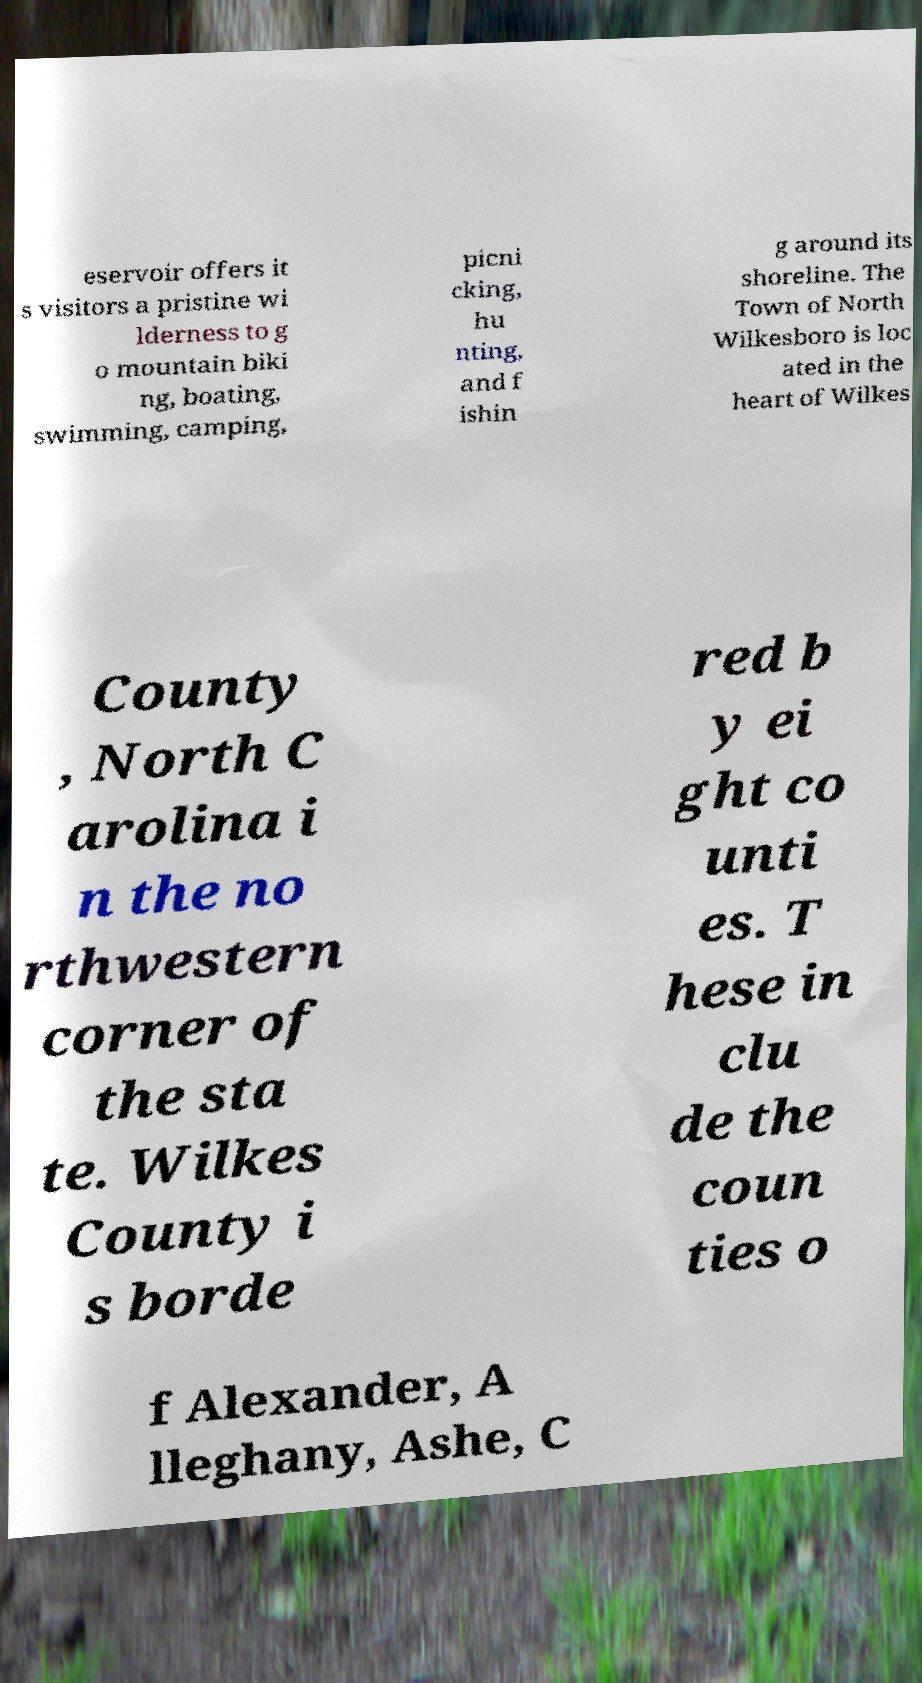Please read and relay the text visible in this image. What does it say? eservoir offers it s visitors a pristine wi lderness to g o mountain biki ng, boating, swimming, camping, picni cking, hu nting, and f ishin g around its shoreline. The Town of North Wilkesboro is loc ated in the heart of Wilkes County , North C arolina i n the no rthwestern corner of the sta te. Wilkes County i s borde red b y ei ght co unti es. T hese in clu de the coun ties o f Alexander, A lleghany, Ashe, C 